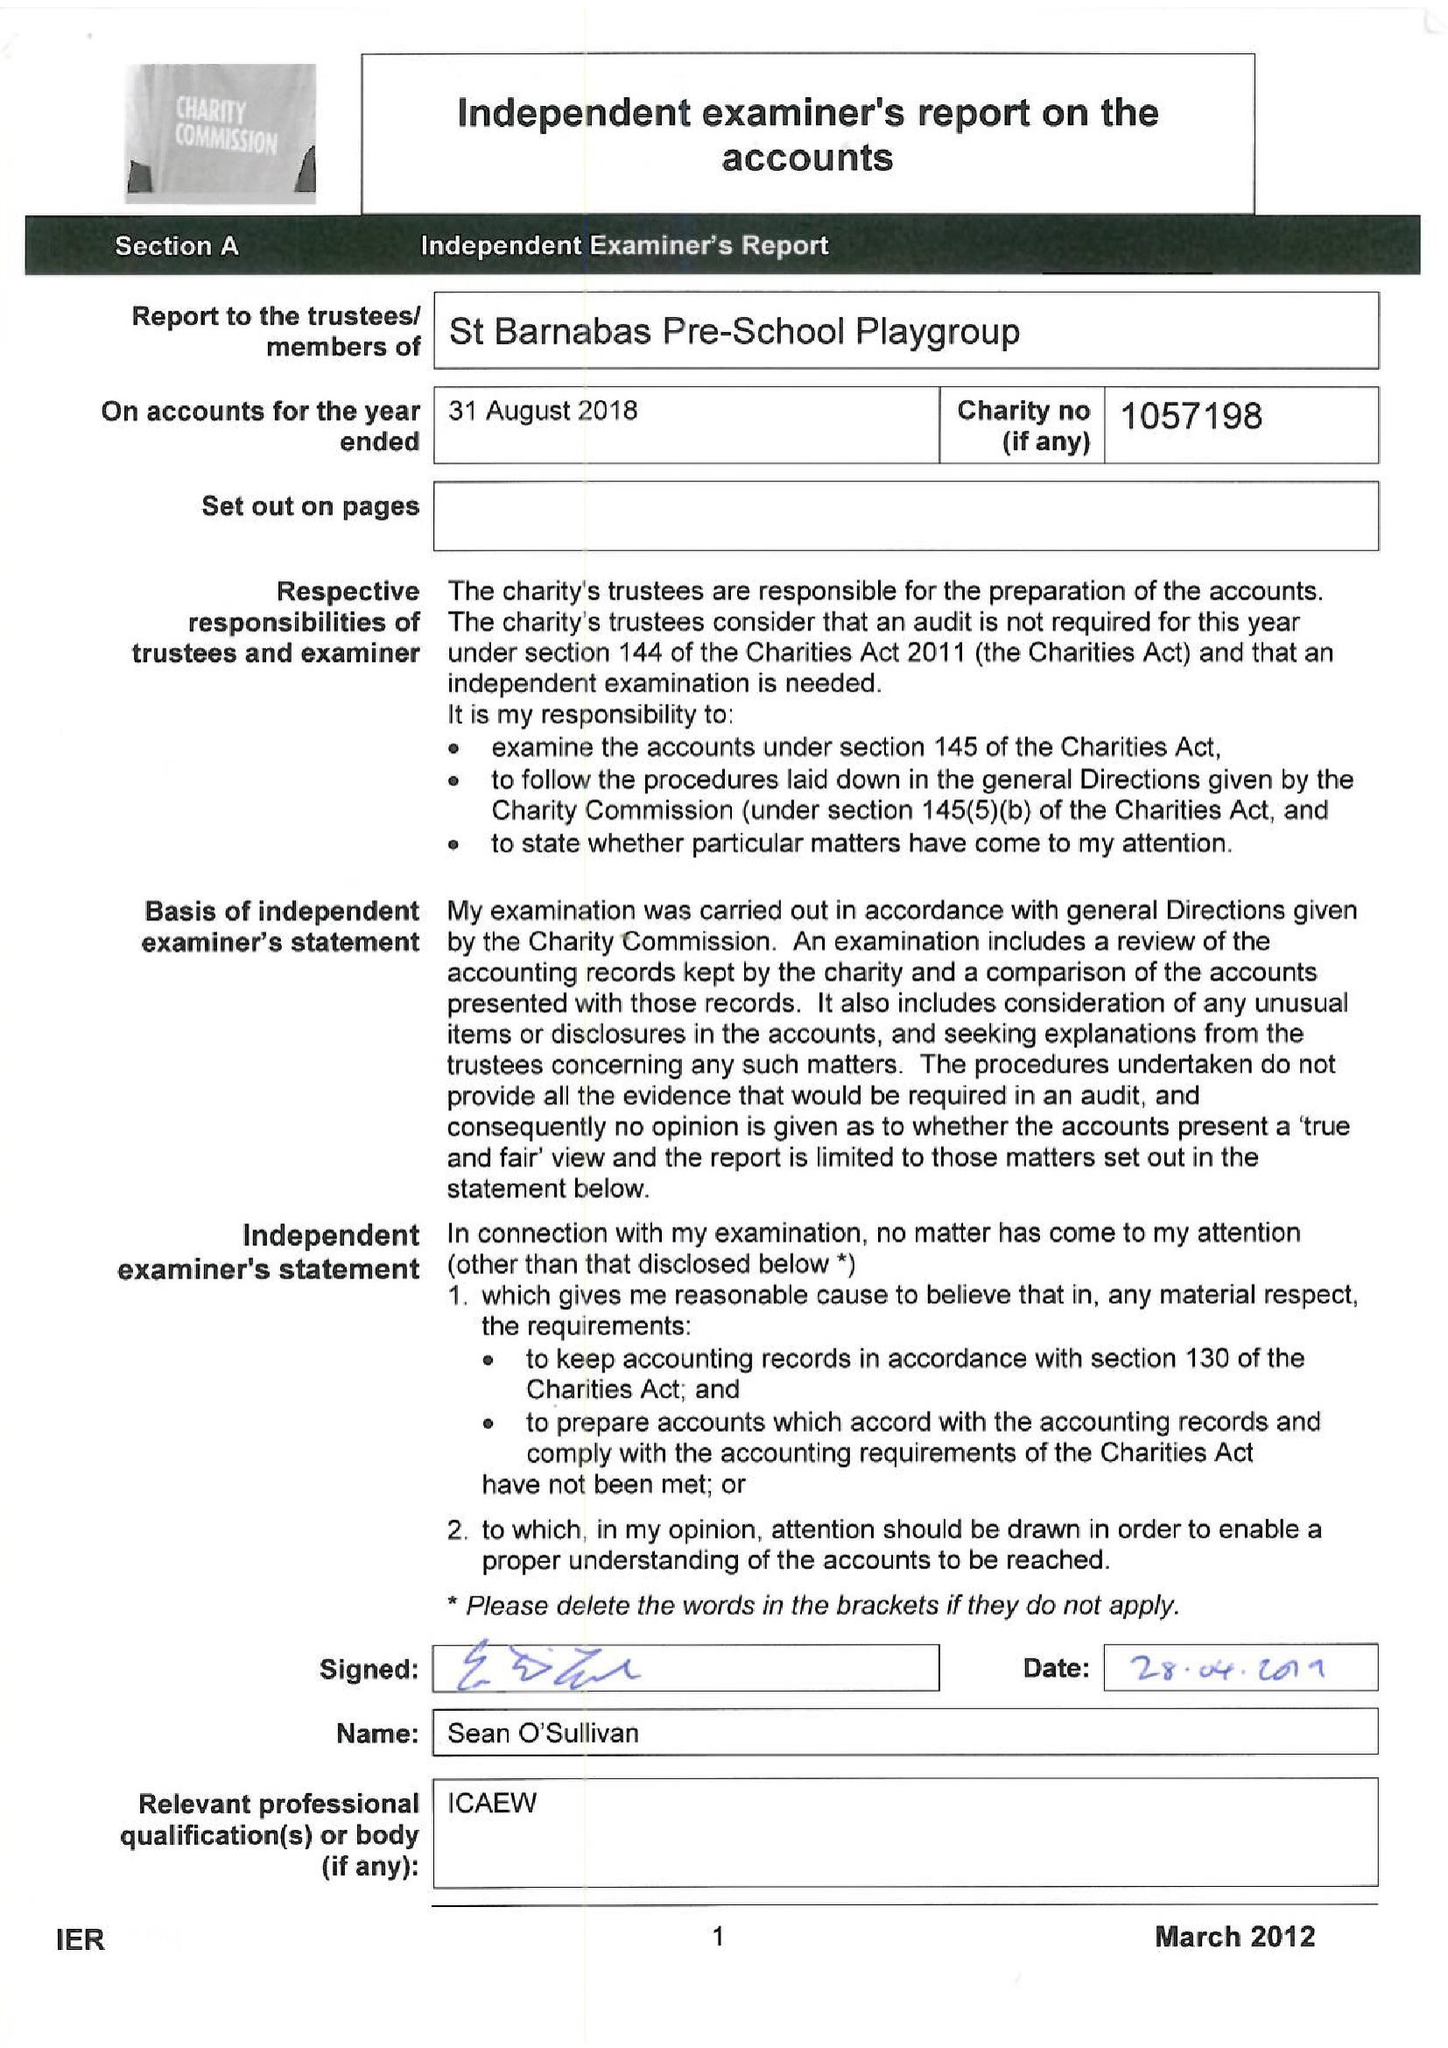What is the value for the report_date?
Answer the question using a single word or phrase. 2018-08-31 